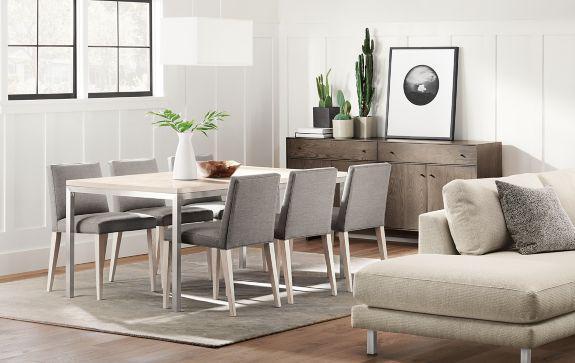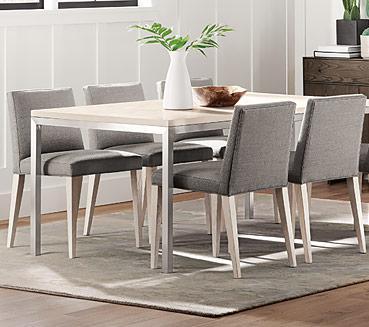The first image is the image on the left, the second image is the image on the right. Considering the images on both sides, is "One image includes a white table with white chairs that feature molded seats." valid? Answer yes or no. No. The first image is the image on the left, the second image is the image on the right. Assess this claim about the two images: "Two rectangular dining tables have chairs only on both long sides.". Correct or not? Answer yes or no. Yes. 